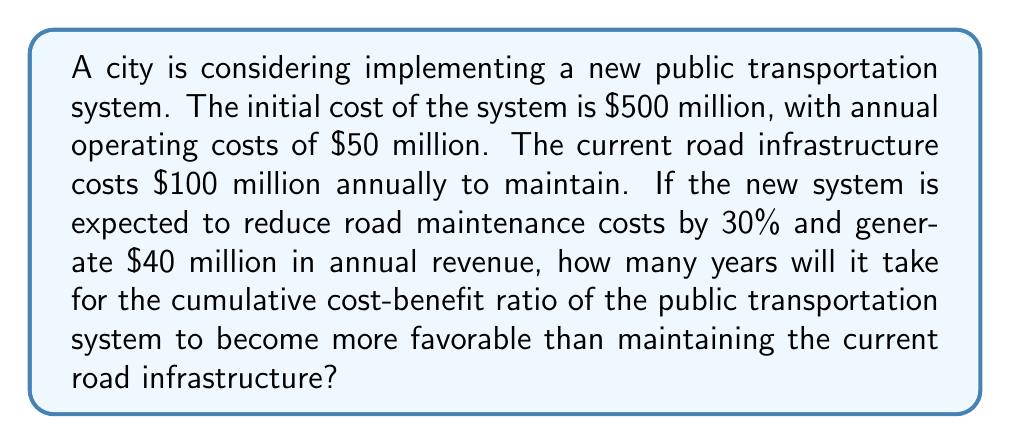Give your solution to this math problem. Let's approach this step-by-step:

1) First, let's define our variables:
   $t$ = number of years
   $C_p(t)$ = cumulative cost of public transportation system after $t$ years
   $C_r(t)$ = cumulative cost of road infrastructure after $t$ years

2) For the public transportation system:
   Initial cost = $500 million
   Annual operating cost = $50 million
   Annual revenue = $40 million
   Net annual cost = $50 million - $40 million = $10 million

   $$C_p(t) = 500 + 10t$$

3) For the road infrastructure:
   Current annual cost = $100 million
   Reduced annual cost = $100 million * (1 - 0.30) = $70 million

   $$C_r(t) = 70t$$

4) We want to find $t$ where $C_p(t) < C_r(t)$:

   $$500 + 10t < 70t$$

5) Solving this inequality:
   $$500 < 60t$$
   $$\frac{500}{60} < t$$
   $$8.33 < t$$

6) Since $t$ must be a whole number of years, we round up to 9 years.
Answer: 9 years 